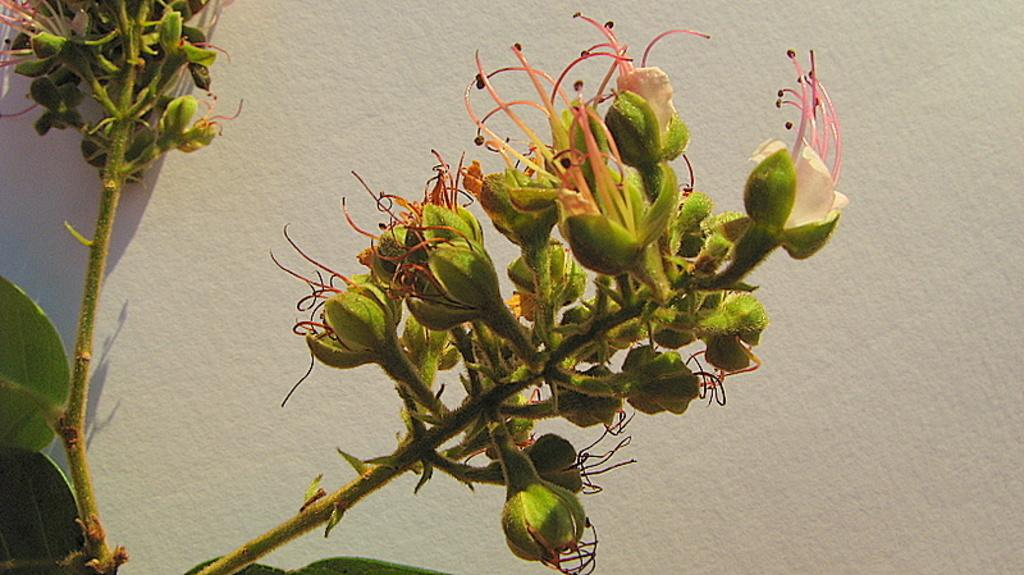What is the main subject in the center of the image? There are flowers in the center of the image. How are the flowers arranged or displayed? The flowers are attached to a wall. What else can be seen in the background of the image? There is a wall visible in the background of the image. Can you tell me how many docks are visible in the image? There are no docks present in the image; it features flowers attached to a wall. What type of horn is being played by the father in the image? There is no father or horn present in the image. 